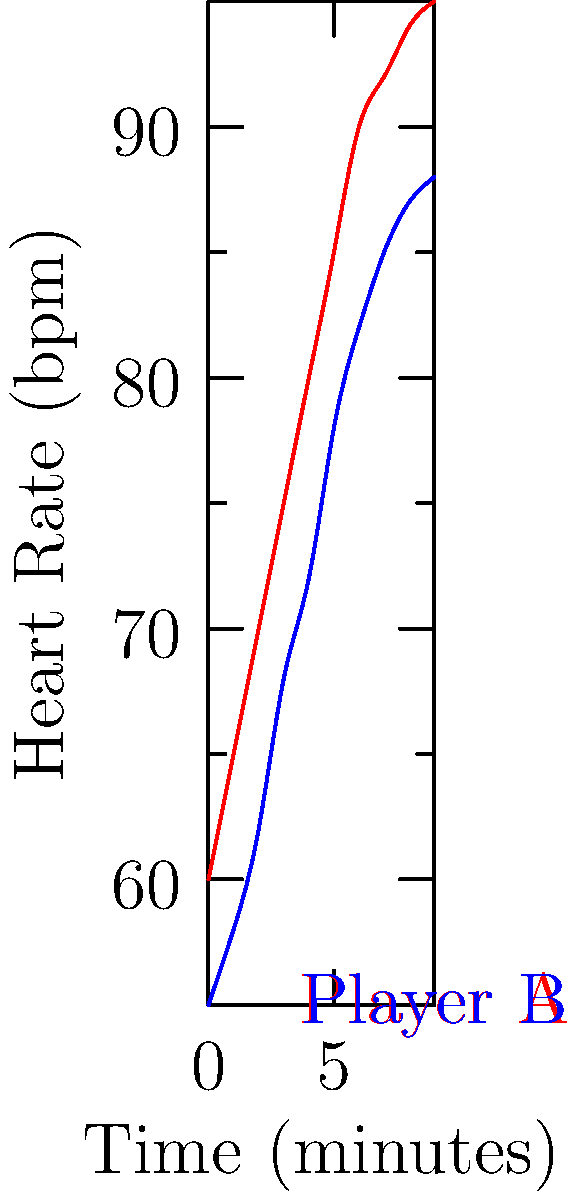Based on the GPS tracking visualization of heart rate data for two players during a 90-minute match, which player would you consider to have better cardiovascular fitness, and why? How might this information influence your tactical decisions as a coach? To analyze the cardiovascular fitness of the players based on the given heart rate data, we need to consider several factors:

1. Resting heart rate: Player B starts with a lower heart rate (55 bpm) compared to Player A (60 bpm), which could indicate better cardiovascular fitness.

2. Rate of increase: Player B's heart rate increases more gradually over time, while Player A's rises more rapidly in the first half of the match.

3. Maximum heart rate: Player A reaches a higher maximum heart rate (95 bpm) compared to Player B (88 bpm).

4. Heart rate stability: Player B's heart rate stabilizes earlier and remains more consistent in the latter part of the match.

5. Recovery potential: Although not shown directly, Player B's lower overall heart rate suggests better recovery potential during the match.

Player B demonstrates better cardiovascular fitness due to:
a) Lower starting heart rate
b) More gradual increase in heart rate
c) Lower maximum heart rate
d) Better heart rate stability

As a coach, this information could influence tactical decisions:
1. Player B might be better suited for endurance-based roles or positions requiring consistent performance throughout the match.
2. Player A might be more effective in high-intensity, shorter duration roles or as a impact substitute.
3. Training programs could be tailored to improve Player A's cardiovascular fitness to match Player B's level.
4. During the match, you might consider giving Player A more rest periods or substituting earlier to maintain overall team performance.
Answer: Player B; lower and more stable heart rate indicates better cardiovascular fitness, allowing for more strategic positioning and endurance-based roles. 